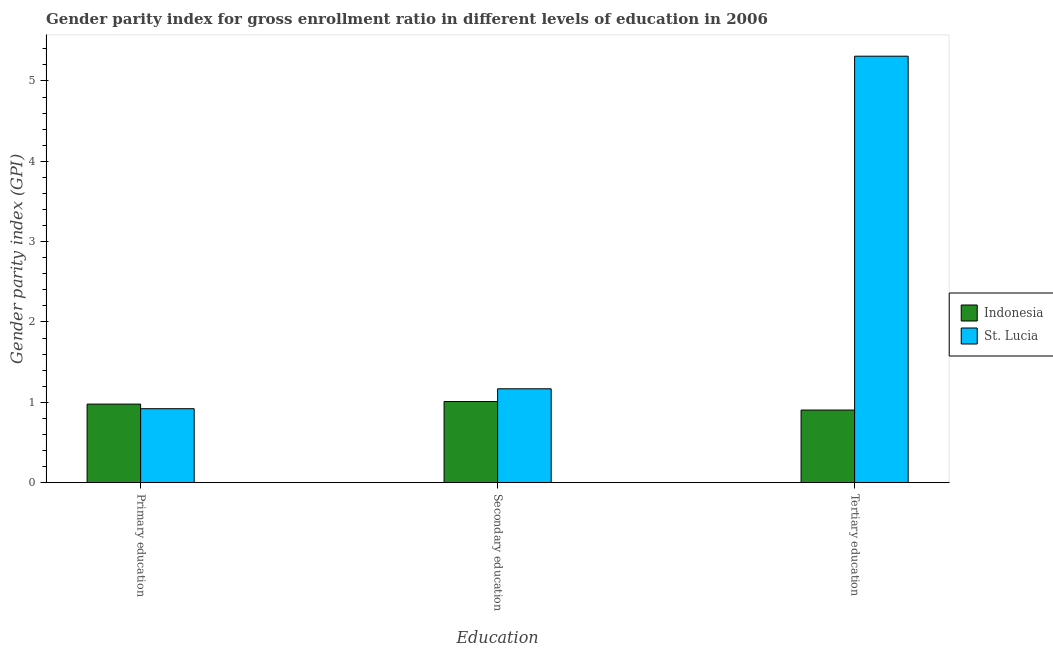How many different coloured bars are there?
Give a very brief answer. 2. Are the number of bars per tick equal to the number of legend labels?
Your answer should be very brief. Yes. Are the number of bars on each tick of the X-axis equal?
Provide a short and direct response. Yes. What is the label of the 1st group of bars from the left?
Offer a very short reply. Primary education. What is the gender parity index in tertiary education in St. Lucia?
Your answer should be compact. 5.31. Across all countries, what is the maximum gender parity index in tertiary education?
Offer a very short reply. 5.31. Across all countries, what is the minimum gender parity index in secondary education?
Provide a short and direct response. 1.01. In which country was the gender parity index in secondary education maximum?
Ensure brevity in your answer.  St. Lucia. In which country was the gender parity index in primary education minimum?
Your answer should be compact. St. Lucia. What is the total gender parity index in secondary education in the graph?
Your answer should be very brief. 2.18. What is the difference between the gender parity index in primary education in Indonesia and that in St. Lucia?
Give a very brief answer. 0.06. What is the difference between the gender parity index in primary education in St. Lucia and the gender parity index in secondary education in Indonesia?
Make the answer very short. -0.09. What is the average gender parity index in primary education per country?
Your response must be concise. 0.95. What is the difference between the gender parity index in secondary education and gender parity index in primary education in St. Lucia?
Give a very brief answer. 0.25. In how many countries, is the gender parity index in tertiary education greater than 2.6 ?
Offer a terse response. 1. What is the ratio of the gender parity index in primary education in St. Lucia to that in Indonesia?
Ensure brevity in your answer.  0.94. Is the gender parity index in secondary education in St. Lucia less than that in Indonesia?
Keep it short and to the point. No. What is the difference between the highest and the second highest gender parity index in primary education?
Provide a succinct answer. 0.06. What is the difference between the highest and the lowest gender parity index in secondary education?
Give a very brief answer. 0.16. In how many countries, is the gender parity index in primary education greater than the average gender parity index in primary education taken over all countries?
Provide a short and direct response. 1. What does the 2nd bar from the left in Primary education represents?
Your answer should be compact. St. Lucia. How many bars are there?
Your response must be concise. 6. Are all the bars in the graph horizontal?
Provide a short and direct response. No. What is the difference between two consecutive major ticks on the Y-axis?
Your answer should be very brief. 1. Are the values on the major ticks of Y-axis written in scientific E-notation?
Offer a very short reply. No. Does the graph contain any zero values?
Give a very brief answer. No. Does the graph contain grids?
Keep it short and to the point. No. How are the legend labels stacked?
Your response must be concise. Vertical. What is the title of the graph?
Keep it short and to the point. Gender parity index for gross enrollment ratio in different levels of education in 2006. What is the label or title of the X-axis?
Ensure brevity in your answer.  Education. What is the label or title of the Y-axis?
Make the answer very short. Gender parity index (GPI). What is the Gender parity index (GPI) in Indonesia in Primary education?
Your response must be concise. 0.98. What is the Gender parity index (GPI) in St. Lucia in Primary education?
Provide a succinct answer. 0.92. What is the Gender parity index (GPI) in Indonesia in Secondary education?
Your answer should be very brief. 1.01. What is the Gender parity index (GPI) in St. Lucia in Secondary education?
Make the answer very short. 1.17. What is the Gender parity index (GPI) in Indonesia in Tertiary education?
Offer a very short reply. 0.9. What is the Gender parity index (GPI) of St. Lucia in Tertiary education?
Ensure brevity in your answer.  5.31. Across all Education, what is the maximum Gender parity index (GPI) in Indonesia?
Offer a terse response. 1.01. Across all Education, what is the maximum Gender parity index (GPI) of St. Lucia?
Your answer should be very brief. 5.31. Across all Education, what is the minimum Gender parity index (GPI) in Indonesia?
Provide a short and direct response. 0.9. Across all Education, what is the minimum Gender parity index (GPI) of St. Lucia?
Your answer should be very brief. 0.92. What is the total Gender parity index (GPI) in Indonesia in the graph?
Ensure brevity in your answer.  2.89. What is the total Gender parity index (GPI) of St. Lucia in the graph?
Keep it short and to the point. 7.4. What is the difference between the Gender parity index (GPI) in Indonesia in Primary education and that in Secondary education?
Your response must be concise. -0.03. What is the difference between the Gender parity index (GPI) in St. Lucia in Primary education and that in Secondary education?
Provide a succinct answer. -0.25. What is the difference between the Gender parity index (GPI) of Indonesia in Primary education and that in Tertiary education?
Provide a short and direct response. 0.07. What is the difference between the Gender parity index (GPI) in St. Lucia in Primary education and that in Tertiary education?
Provide a short and direct response. -4.39. What is the difference between the Gender parity index (GPI) of Indonesia in Secondary education and that in Tertiary education?
Provide a short and direct response. 0.11. What is the difference between the Gender parity index (GPI) of St. Lucia in Secondary education and that in Tertiary education?
Make the answer very short. -4.14. What is the difference between the Gender parity index (GPI) of Indonesia in Primary education and the Gender parity index (GPI) of St. Lucia in Secondary education?
Offer a very short reply. -0.19. What is the difference between the Gender parity index (GPI) of Indonesia in Primary education and the Gender parity index (GPI) of St. Lucia in Tertiary education?
Offer a terse response. -4.33. What is the difference between the Gender parity index (GPI) in Indonesia in Secondary education and the Gender parity index (GPI) in St. Lucia in Tertiary education?
Provide a succinct answer. -4.3. What is the average Gender parity index (GPI) in Indonesia per Education?
Provide a succinct answer. 0.96. What is the average Gender parity index (GPI) of St. Lucia per Education?
Provide a short and direct response. 2.47. What is the difference between the Gender parity index (GPI) in Indonesia and Gender parity index (GPI) in St. Lucia in Primary education?
Keep it short and to the point. 0.06. What is the difference between the Gender parity index (GPI) of Indonesia and Gender parity index (GPI) of St. Lucia in Secondary education?
Your answer should be very brief. -0.16. What is the difference between the Gender parity index (GPI) of Indonesia and Gender parity index (GPI) of St. Lucia in Tertiary education?
Ensure brevity in your answer.  -4.41. What is the ratio of the Gender parity index (GPI) in Indonesia in Primary education to that in Secondary education?
Provide a short and direct response. 0.97. What is the ratio of the Gender parity index (GPI) of St. Lucia in Primary education to that in Secondary education?
Keep it short and to the point. 0.79. What is the ratio of the Gender parity index (GPI) in Indonesia in Primary education to that in Tertiary education?
Offer a very short reply. 1.08. What is the ratio of the Gender parity index (GPI) in St. Lucia in Primary education to that in Tertiary education?
Offer a terse response. 0.17. What is the ratio of the Gender parity index (GPI) in Indonesia in Secondary education to that in Tertiary education?
Offer a very short reply. 1.12. What is the ratio of the Gender parity index (GPI) of St. Lucia in Secondary education to that in Tertiary education?
Your response must be concise. 0.22. What is the difference between the highest and the second highest Gender parity index (GPI) of Indonesia?
Offer a terse response. 0.03. What is the difference between the highest and the second highest Gender parity index (GPI) of St. Lucia?
Provide a short and direct response. 4.14. What is the difference between the highest and the lowest Gender parity index (GPI) of Indonesia?
Your answer should be compact. 0.11. What is the difference between the highest and the lowest Gender parity index (GPI) of St. Lucia?
Offer a terse response. 4.39. 